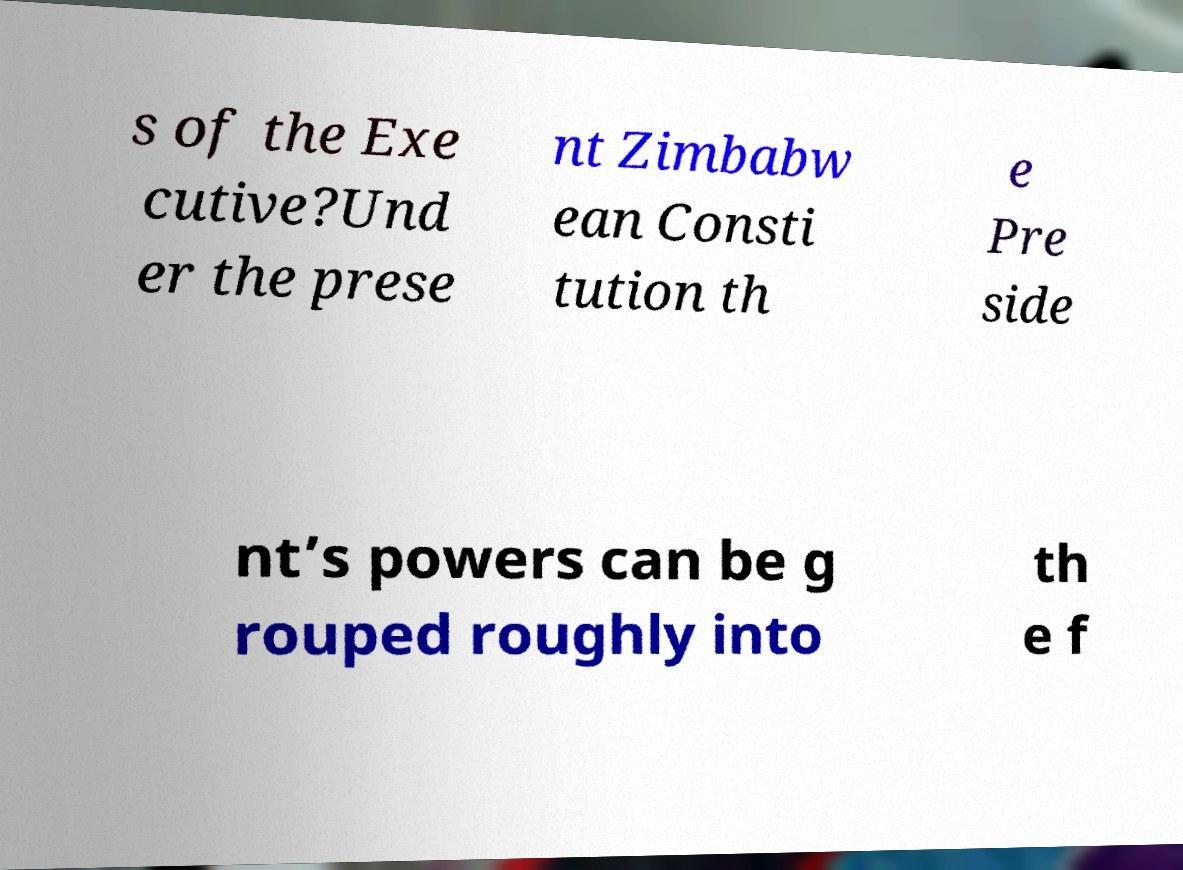Could you assist in decoding the text presented in this image and type it out clearly? s of the Exe cutive?Und er the prese nt Zimbabw ean Consti tution th e Pre side nt’s powers can be g rouped roughly into th e f 